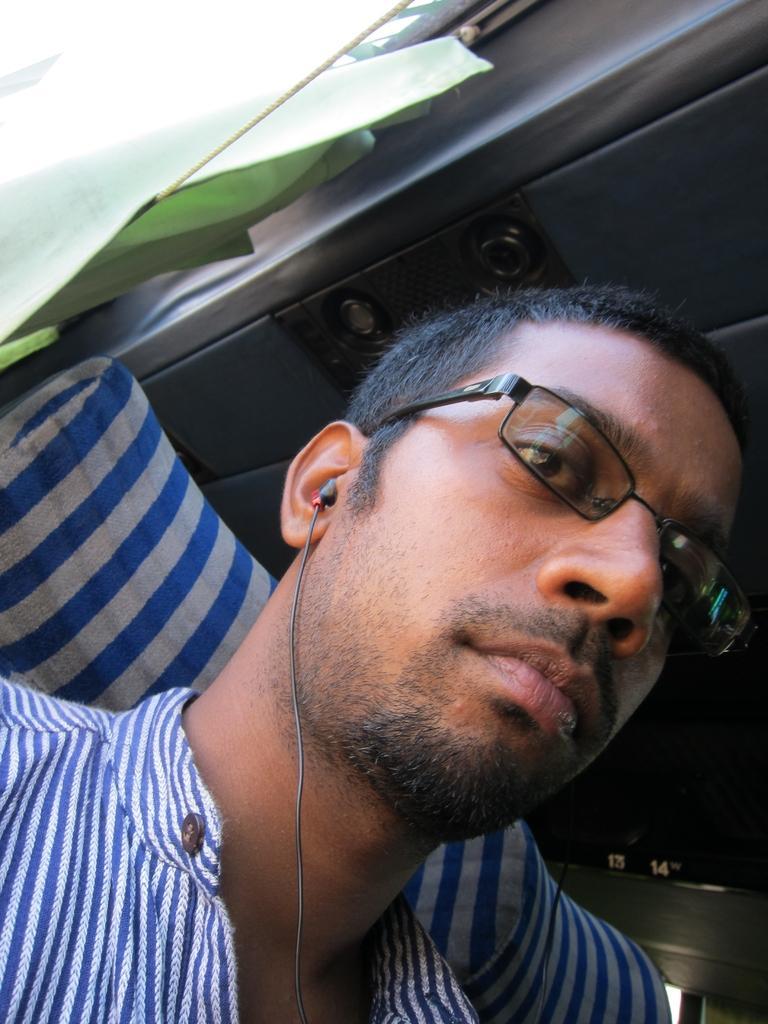In one or two sentences, can you explain what this image depicts? In this image I can see a man, I can see he is wearing blue and white t shirt, specs and I can see earphone. I can also see green colour curtain in background. 